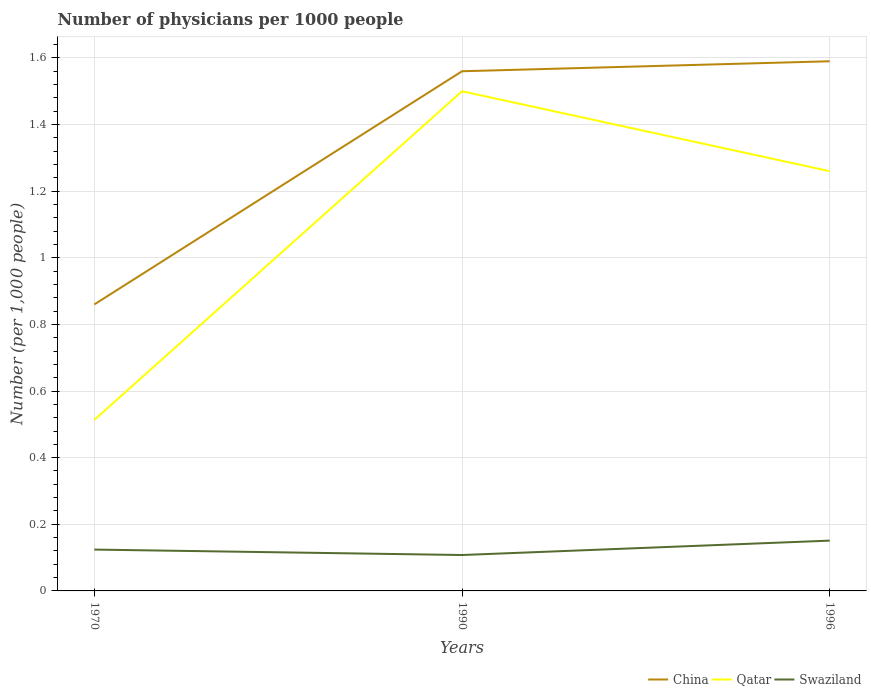How many different coloured lines are there?
Offer a terse response. 3. Is the number of lines equal to the number of legend labels?
Provide a short and direct response. Yes. Across all years, what is the maximum number of physicians in Swaziland?
Keep it short and to the point. 0.11. What is the total number of physicians in Qatar in the graph?
Offer a terse response. -0.99. What is the difference between the highest and the second highest number of physicians in Qatar?
Offer a very short reply. 0.99. What is the difference between the highest and the lowest number of physicians in China?
Make the answer very short. 2. How many years are there in the graph?
Your answer should be compact. 3. Are the values on the major ticks of Y-axis written in scientific E-notation?
Provide a succinct answer. No. Does the graph contain any zero values?
Give a very brief answer. No. Does the graph contain grids?
Offer a terse response. Yes. Where does the legend appear in the graph?
Offer a very short reply. Bottom right. How are the legend labels stacked?
Offer a very short reply. Horizontal. What is the title of the graph?
Your answer should be very brief. Number of physicians per 1000 people. Does "Namibia" appear as one of the legend labels in the graph?
Provide a succinct answer. No. What is the label or title of the Y-axis?
Provide a short and direct response. Number (per 1,0 people). What is the Number (per 1,000 people) of China in 1970?
Offer a very short reply. 0.86. What is the Number (per 1,000 people) in Qatar in 1970?
Your answer should be very brief. 0.51. What is the Number (per 1,000 people) in Swaziland in 1970?
Give a very brief answer. 0.12. What is the Number (per 1,000 people) in China in 1990?
Your response must be concise. 1.56. What is the Number (per 1,000 people) in Qatar in 1990?
Provide a short and direct response. 1.5. What is the Number (per 1,000 people) of Swaziland in 1990?
Offer a very short reply. 0.11. What is the Number (per 1,000 people) of China in 1996?
Make the answer very short. 1.59. What is the Number (per 1,000 people) of Qatar in 1996?
Your answer should be compact. 1.26. What is the Number (per 1,000 people) in Swaziland in 1996?
Your answer should be compact. 0.15. Across all years, what is the maximum Number (per 1,000 people) of China?
Ensure brevity in your answer.  1.59. Across all years, what is the maximum Number (per 1,000 people) of Qatar?
Provide a short and direct response. 1.5. Across all years, what is the maximum Number (per 1,000 people) in Swaziland?
Keep it short and to the point. 0.15. Across all years, what is the minimum Number (per 1,000 people) of China?
Give a very brief answer. 0.86. Across all years, what is the minimum Number (per 1,000 people) of Qatar?
Make the answer very short. 0.51. Across all years, what is the minimum Number (per 1,000 people) in Swaziland?
Keep it short and to the point. 0.11. What is the total Number (per 1,000 people) in China in the graph?
Make the answer very short. 4.01. What is the total Number (per 1,000 people) of Qatar in the graph?
Ensure brevity in your answer.  3.27. What is the total Number (per 1,000 people) of Swaziland in the graph?
Provide a succinct answer. 0.38. What is the difference between the Number (per 1,000 people) in China in 1970 and that in 1990?
Give a very brief answer. -0.7. What is the difference between the Number (per 1,000 people) in Qatar in 1970 and that in 1990?
Provide a short and direct response. -0.99. What is the difference between the Number (per 1,000 people) of Swaziland in 1970 and that in 1990?
Provide a short and direct response. 0.02. What is the difference between the Number (per 1,000 people) in China in 1970 and that in 1996?
Keep it short and to the point. -0.73. What is the difference between the Number (per 1,000 people) of Qatar in 1970 and that in 1996?
Ensure brevity in your answer.  -0.75. What is the difference between the Number (per 1,000 people) in Swaziland in 1970 and that in 1996?
Your answer should be compact. -0.03. What is the difference between the Number (per 1,000 people) of China in 1990 and that in 1996?
Your answer should be very brief. -0.03. What is the difference between the Number (per 1,000 people) in Qatar in 1990 and that in 1996?
Your answer should be very brief. 0.24. What is the difference between the Number (per 1,000 people) in Swaziland in 1990 and that in 1996?
Your answer should be compact. -0.04. What is the difference between the Number (per 1,000 people) of China in 1970 and the Number (per 1,000 people) of Qatar in 1990?
Give a very brief answer. -0.64. What is the difference between the Number (per 1,000 people) of China in 1970 and the Number (per 1,000 people) of Swaziland in 1990?
Provide a short and direct response. 0.75. What is the difference between the Number (per 1,000 people) of Qatar in 1970 and the Number (per 1,000 people) of Swaziland in 1990?
Your answer should be very brief. 0.41. What is the difference between the Number (per 1,000 people) of China in 1970 and the Number (per 1,000 people) of Qatar in 1996?
Keep it short and to the point. -0.4. What is the difference between the Number (per 1,000 people) in China in 1970 and the Number (per 1,000 people) in Swaziland in 1996?
Give a very brief answer. 0.71. What is the difference between the Number (per 1,000 people) of Qatar in 1970 and the Number (per 1,000 people) of Swaziland in 1996?
Ensure brevity in your answer.  0.36. What is the difference between the Number (per 1,000 people) in China in 1990 and the Number (per 1,000 people) in Swaziland in 1996?
Make the answer very short. 1.41. What is the difference between the Number (per 1,000 people) of Qatar in 1990 and the Number (per 1,000 people) of Swaziland in 1996?
Provide a succinct answer. 1.35. What is the average Number (per 1,000 people) of China per year?
Your answer should be very brief. 1.34. What is the average Number (per 1,000 people) in Qatar per year?
Provide a short and direct response. 1.09. What is the average Number (per 1,000 people) in Swaziland per year?
Ensure brevity in your answer.  0.13. In the year 1970, what is the difference between the Number (per 1,000 people) in China and Number (per 1,000 people) in Qatar?
Offer a terse response. 0.35. In the year 1970, what is the difference between the Number (per 1,000 people) in China and Number (per 1,000 people) in Swaziland?
Make the answer very short. 0.74. In the year 1970, what is the difference between the Number (per 1,000 people) in Qatar and Number (per 1,000 people) in Swaziland?
Give a very brief answer. 0.39. In the year 1990, what is the difference between the Number (per 1,000 people) of China and Number (per 1,000 people) of Swaziland?
Make the answer very short. 1.45. In the year 1990, what is the difference between the Number (per 1,000 people) of Qatar and Number (per 1,000 people) of Swaziland?
Provide a short and direct response. 1.39. In the year 1996, what is the difference between the Number (per 1,000 people) in China and Number (per 1,000 people) in Qatar?
Keep it short and to the point. 0.33. In the year 1996, what is the difference between the Number (per 1,000 people) in China and Number (per 1,000 people) in Swaziland?
Make the answer very short. 1.44. In the year 1996, what is the difference between the Number (per 1,000 people) in Qatar and Number (per 1,000 people) in Swaziland?
Make the answer very short. 1.11. What is the ratio of the Number (per 1,000 people) of China in 1970 to that in 1990?
Your answer should be compact. 0.55. What is the ratio of the Number (per 1,000 people) in Qatar in 1970 to that in 1990?
Give a very brief answer. 0.34. What is the ratio of the Number (per 1,000 people) of Swaziland in 1970 to that in 1990?
Offer a very short reply. 1.15. What is the ratio of the Number (per 1,000 people) of China in 1970 to that in 1996?
Give a very brief answer. 0.54. What is the ratio of the Number (per 1,000 people) of Qatar in 1970 to that in 1996?
Offer a very short reply. 0.41. What is the ratio of the Number (per 1,000 people) of Swaziland in 1970 to that in 1996?
Make the answer very short. 0.82. What is the ratio of the Number (per 1,000 people) in China in 1990 to that in 1996?
Provide a short and direct response. 0.98. What is the ratio of the Number (per 1,000 people) of Qatar in 1990 to that in 1996?
Provide a succinct answer. 1.19. What is the ratio of the Number (per 1,000 people) in Swaziland in 1990 to that in 1996?
Your answer should be compact. 0.71. What is the difference between the highest and the second highest Number (per 1,000 people) in Qatar?
Your response must be concise. 0.24. What is the difference between the highest and the second highest Number (per 1,000 people) of Swaziland?
Provide a succinct answer. 0.03. What is the difference between the highest and the lowest Number (per 1,000 people) of China?
Ensure brevity in your answer.  0.73. What is the difference between the highest and the lowest Number (per 1,000 people) in Qatar?
Provide a short and direct response. 0.99. What is the difference between the highest and the lowest Number (per 1,000 people) of Swaziland?
Your answer should be very brief. 0.04. 